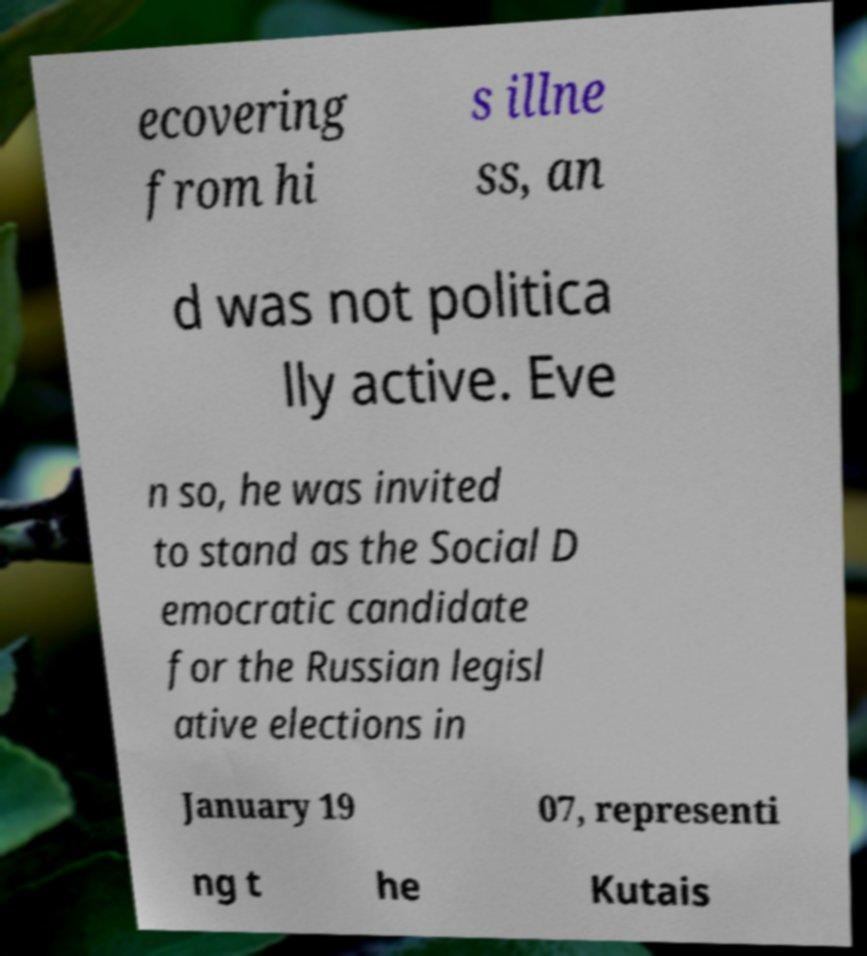Can you accurately transcribe the text from the provided image for me? ecovering from hi s illne ss, an d was not politica lly active. Eve n so, he was invited to stand as the Social D emocratic candidate for the Russian legisl ative elections in January 19 07, representi ng t he Kutais 